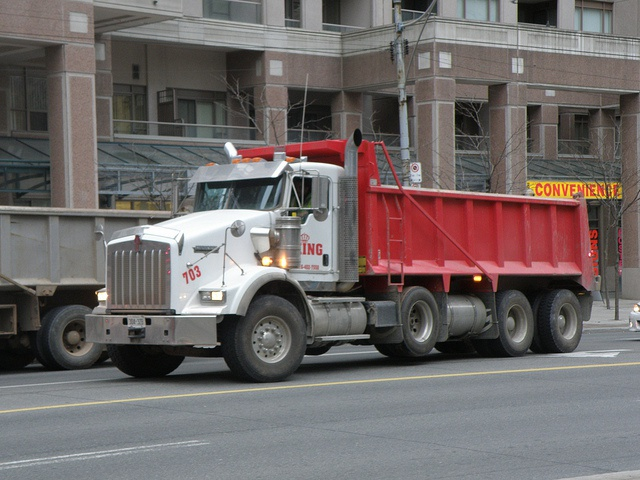Describe the objects in this image and their specific colors. I can see truck in gray, black, brown, and lightgray tones, truck in gray and black tones, and car in gray, darkgray, lightgray, and pink tones in this image. 